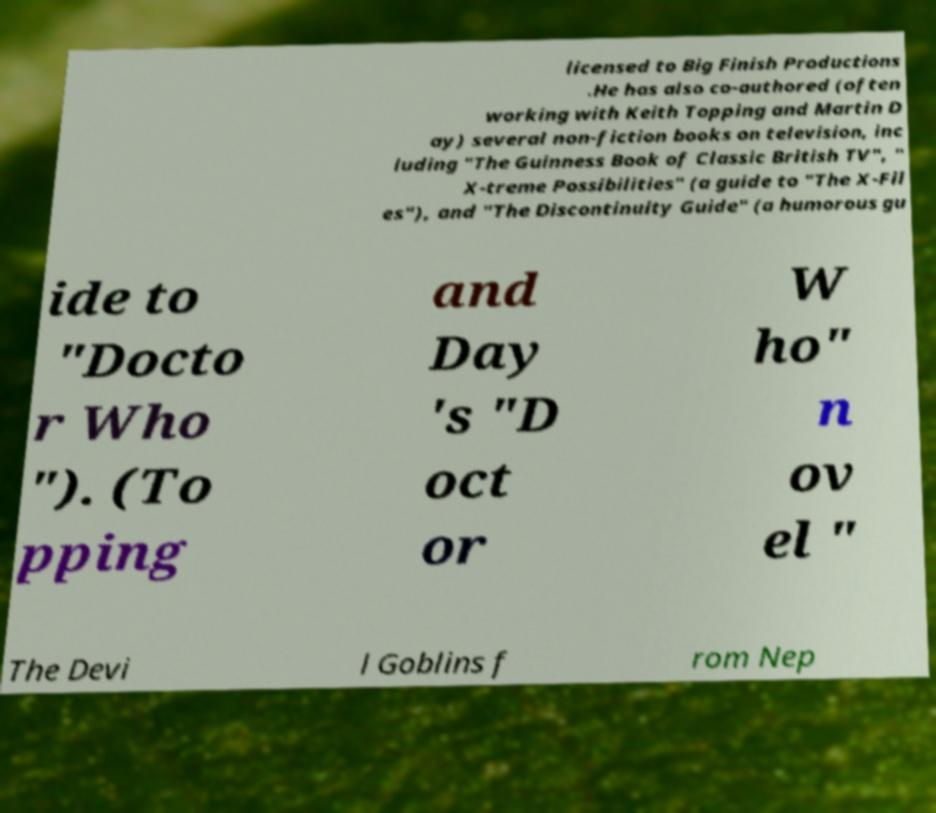Could you assist in decoding the text presented in this image and type it out clearly? licensed to Big Finish Productions .He has also co-authored (often working with Keith Topping and Martin D ay) several non-fiction books on television, inc luding "The Guinness Book of Classic British TV", " X-treme Possibilities" (a guide to "The X-Fil es"), and "The Discontinuity Guide" (a humorous gu ide to "Docto r Who "). (To pping and Day 's "D oct or W ho" n ov el " The Devi l Goblins f rom Nep 